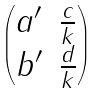Convert formula to latex. <formula><loc_0><loc_0><loc_500><loc_500>\begin{pmatrix} a ^ { \prime } & \frac { c } { k } \\ b ^ { \prime } & \frac { d } { k } \end{pmatrix}</formula> 